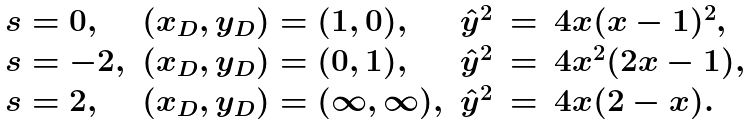Convert formula to latex. <formula><loc_0><loc_0><loc_500><loc_500>\begin{array} { l l r c l } s = 0 , & ( x _ { D } , y _ { D } ) = ( 1 , 0 ) , & \hat { y } ^ { 2 } & = & 4 x ( x - 1 ) ^ { 2 } , \\ s = - 2 , & ( x _ { D } , y _ { D } ) = ( 0 , 1 ) , & \hat { y } ^ { 2 } & = & 4 x ^ { 2 } ( 2 x - 1 ) , \\ s = 2 , & ( x _ { D } , y _ { D } ) = ( \infty , \infty ) , & \hat { y } ^ { 2 } & = & 4 x ( 2 - x ) . \end{array}</formula> 